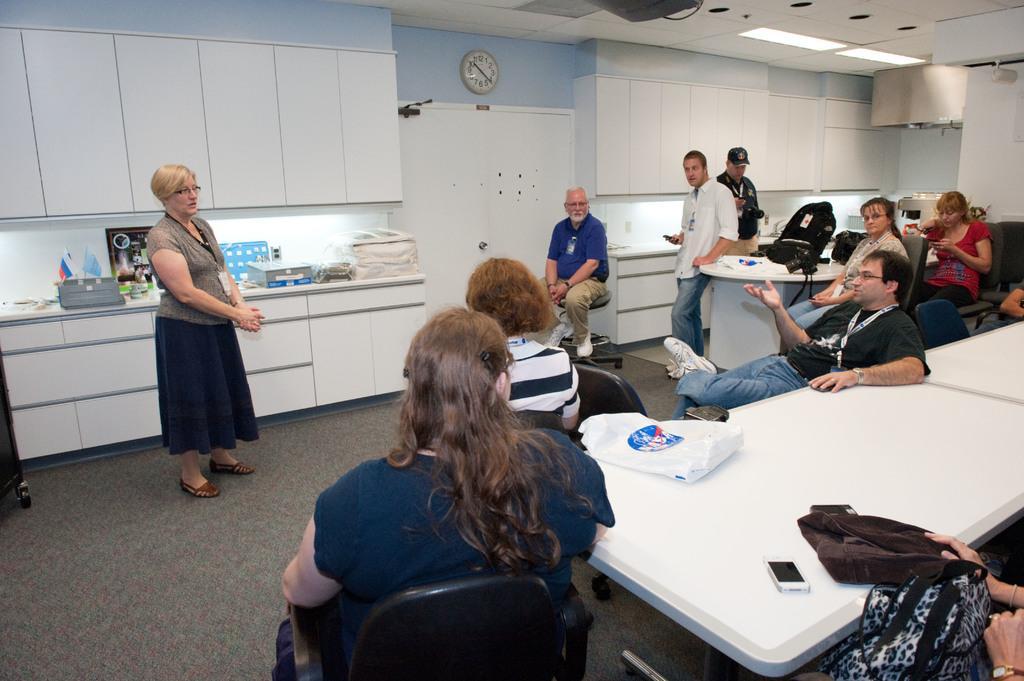Please provide a concise description of this image. In this image I can see people among them some are sitting on chairs and some are standing. Here I can see some tables. On the tables I can see a bag, a mobile and some other objects. Here I can see cupboards, a clock and other objects attached to the wall. Here I can see a table which has some objects on it. 